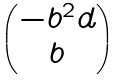<formula> <loc_0><loc_0><loc_500><loc_500>\begin{pmatrix} - b ^ { 2 } d \\ b \end{pmatrix}</formula> 